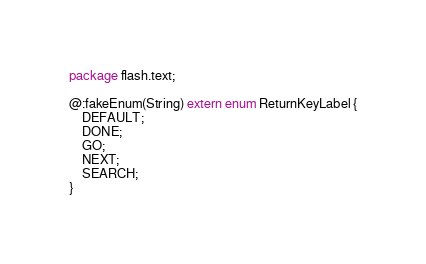<code> <loc_0><loc_0><loc_500><loc_500><_Haxe_>package flash.text;

@:fakeEnum(String) extern enum ReturnKeyLabel {
	DEFAULT;
	DONE;
	GO;
	NEXT;
	SEARCH;
}
</code> 